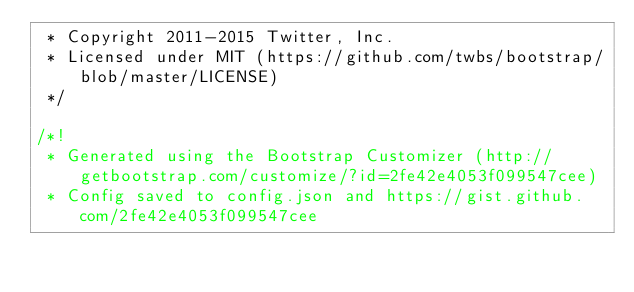Convert code to text. <code><loc_0><loc_0><loc_500><loc_500><_CSS_> * Copyright 2011-2015 Twitter, Inc.
 * Licensed under MIT (https://github.com/twbs/bootstrap/blob/master/LICENSE)
 */

/*!
 * Generated using the Bootstrap Customizer (http://getbootstrap.com/customize/?id=2fe42e4053f099547cee)
 * Config saved to config.json and https://gist.github.com/2fe42e4053f099547cee</code> 